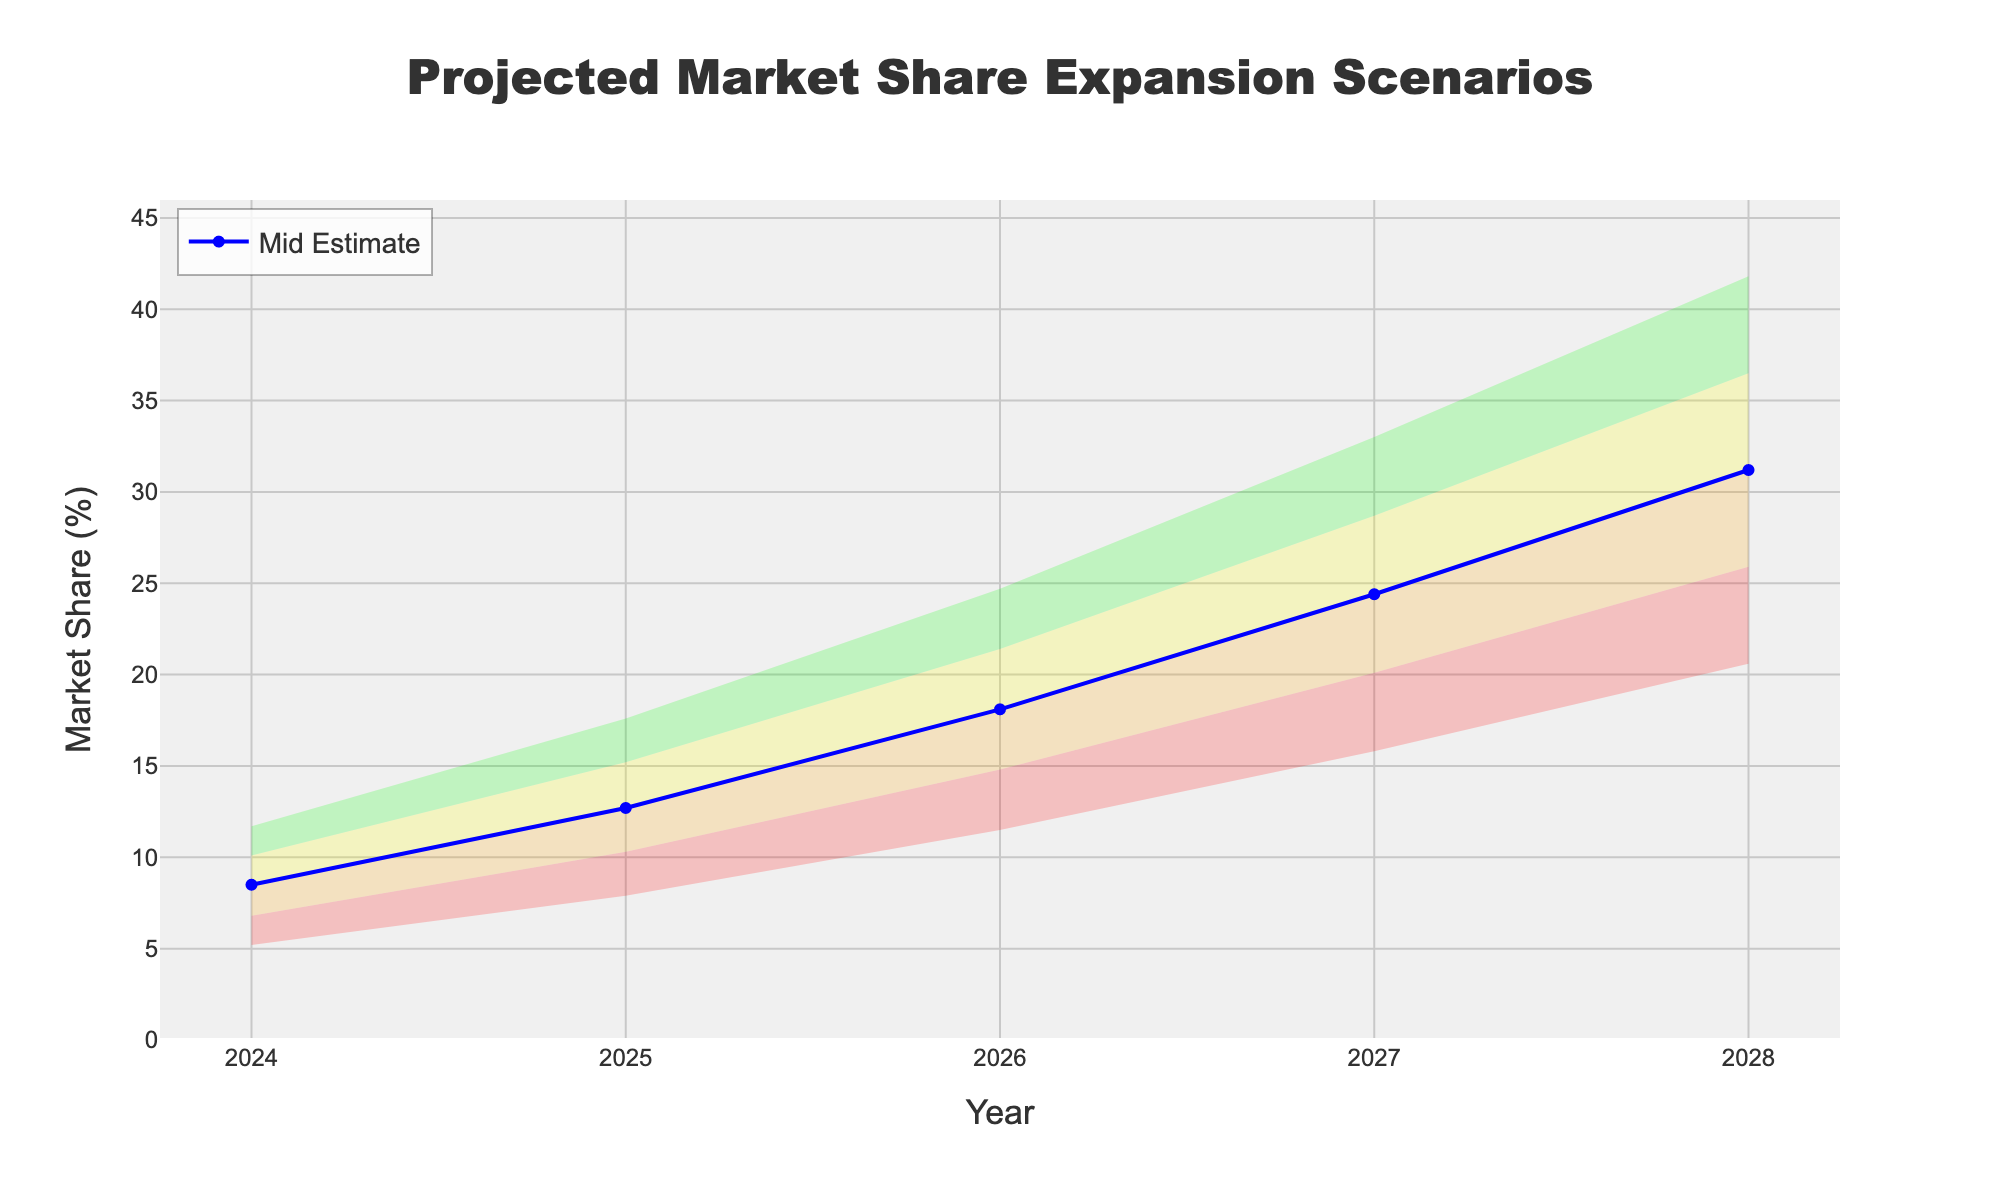what is the title of the chart? The title is usually placed at the top center of the figure. For this chart, it reads "Projected Market Share Expansion Scenarios".
Answer: Projected Market Share Expansion Scenarios what is the market share for the Mid Estimate in 2027? Find the year 2027 on the x-axis and then find the corresponding value for the Mid Estimate on the y-axis. It shows 24.4%.
Answer: 24.4% how many projections are displayed for each year? Each year has five projections, namely Low Estimate, Low-Mid Estimate, Mid Estimate, Mid-High Estimate, and High Estimate.
Answer: Five what's the difference between the High Estimate and the Low Estimate in 2026? For year 2026, find the High Estimate (24.7%) and the Low Estimate (11.5%) and then subtract the Low Estimate from the High Estimate. (24.7 - 11.5) = 13.2.
Answer: 13.2 how does the Mid Estimate trend from 2024 to 2028? Follow the Mid Estimate values from 2024 to 2028 (8.5, 12.7, 18.1, 24.4, 31.2) and observe that they are consistently increasing each year.
Answer: Increasing which year shows the greatest range between Low and High Estimates? For each year, find the difference between Low Estimate and High Estimate, then compare these ranges: 2024 (6.5), 2025 (9.7), 2026 (13.2), 2027 (17.2), 2028 (21.2). 2028 has the greatest range.
Answer: 2028 compare the Mid-High Estimate in 2025 with the Mid Estimate in 2026. Which is higher? Find the values for Mid-High Estimate in 2025 (15.2%) and Mid Estimate in 2026 (18.1%), and compare them. 18.1% is higher than 15.2%.
Answer: Mid Estimate in 2026 what's the average market share of the Mid Estimate over the five years? Add the Mid Estimate values for each year (8.5 + 12.7 + 18.1 + 24.4 + 31.2) which equals 94.9, then divide by 5 to find the average (94.9 / 5).
Answer: 18.98 by how much does the Low-Mid Estimate increase from 2024 to 2028? Find the Low-Mid Estimate values for 2024 (6.8%) and 2028 (25.9%), then subtract the 2024 value from the 2028 value (25.9 - 6.8).
Answer: 19.1 